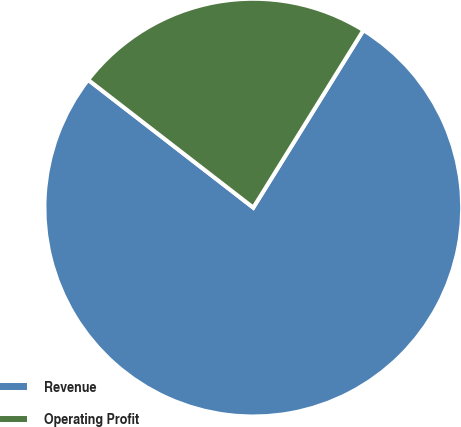Convert chart to OTSL. <chart><loc_0><loc_0><loc_500><loc_500><pie_chart><fcel>Revenue<fcel>Operating Profit<nl><fcel>76.64%<fcel>23.36%<nl></chart> 